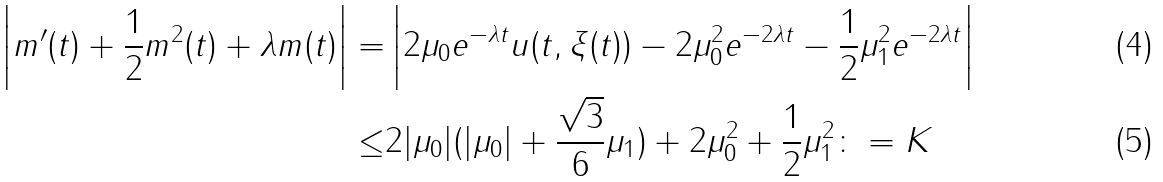Convert formula to latex. <formula><loc_0><loc_0><loc_500><loc_500>\left | m ^ { \prime } ( t ) + \frac { 1 } { 2 } m ^ { 2 } ( t ) + \lambda m ( t ) \right | = & \left | 2 \mu _ { 0 } e ^ { - \lambda t } u ( t , \xi ( t ) ) - 2 \mu _ { 0 } ^ { 2 } e ^ { - 2 \lambda t } - \frac { 1 } { 2 } \mu _ { 1 } ^ { 2 } e ^ { - 2 \lambda t } \right | \\ \leq & 2 | \mu _ { 0 } | ( | \mu _ { 0 } | + \frac { \sqrt { 3 } } { 6 } \mu _ { 1 } ) + 2 \mu _ { 0 } ^ { 2 } + \frac { 1 } { 2 } \mu _ { 1 } ^ { 2 } \colon = K</formula> 